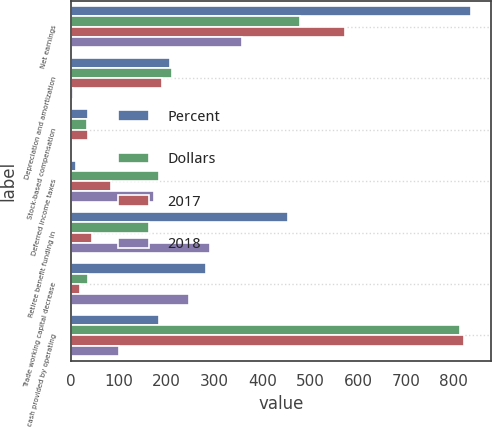Convert chart to OTSL. <chart><loc_0><loc_0><loc_500><loc_500><stacked_bar_chart><ecel><fcel>Net earnings<fcel>Depreciation and amortization<fcel>Stock-based compensation<fcel>Deferred income taxes<fcel>Retiree benefit funding in<fcel>Trade working capital decrease<fcel>Net cash provided by operating<nl><fcel>Percent<fcel>836<fcel>207<fcel>36<fcel>10<fcel>454<fcel>283<fcel>184<nl><fcel>Dollars<fcel>479<fcel>211<fcel>34<fcel>184<fcel>163<fcel>37<fcel>814<nl><fcel>2017<fcel>573<fcel>191<fcel>36<fcel>85<fcel>44<fcel>19<fcel>822<nl><fcel>2018<fcel>357<fcel>4<fcel>2<fcel>174<fcel>291<fcel>246<fcel>100<nl></chart> 